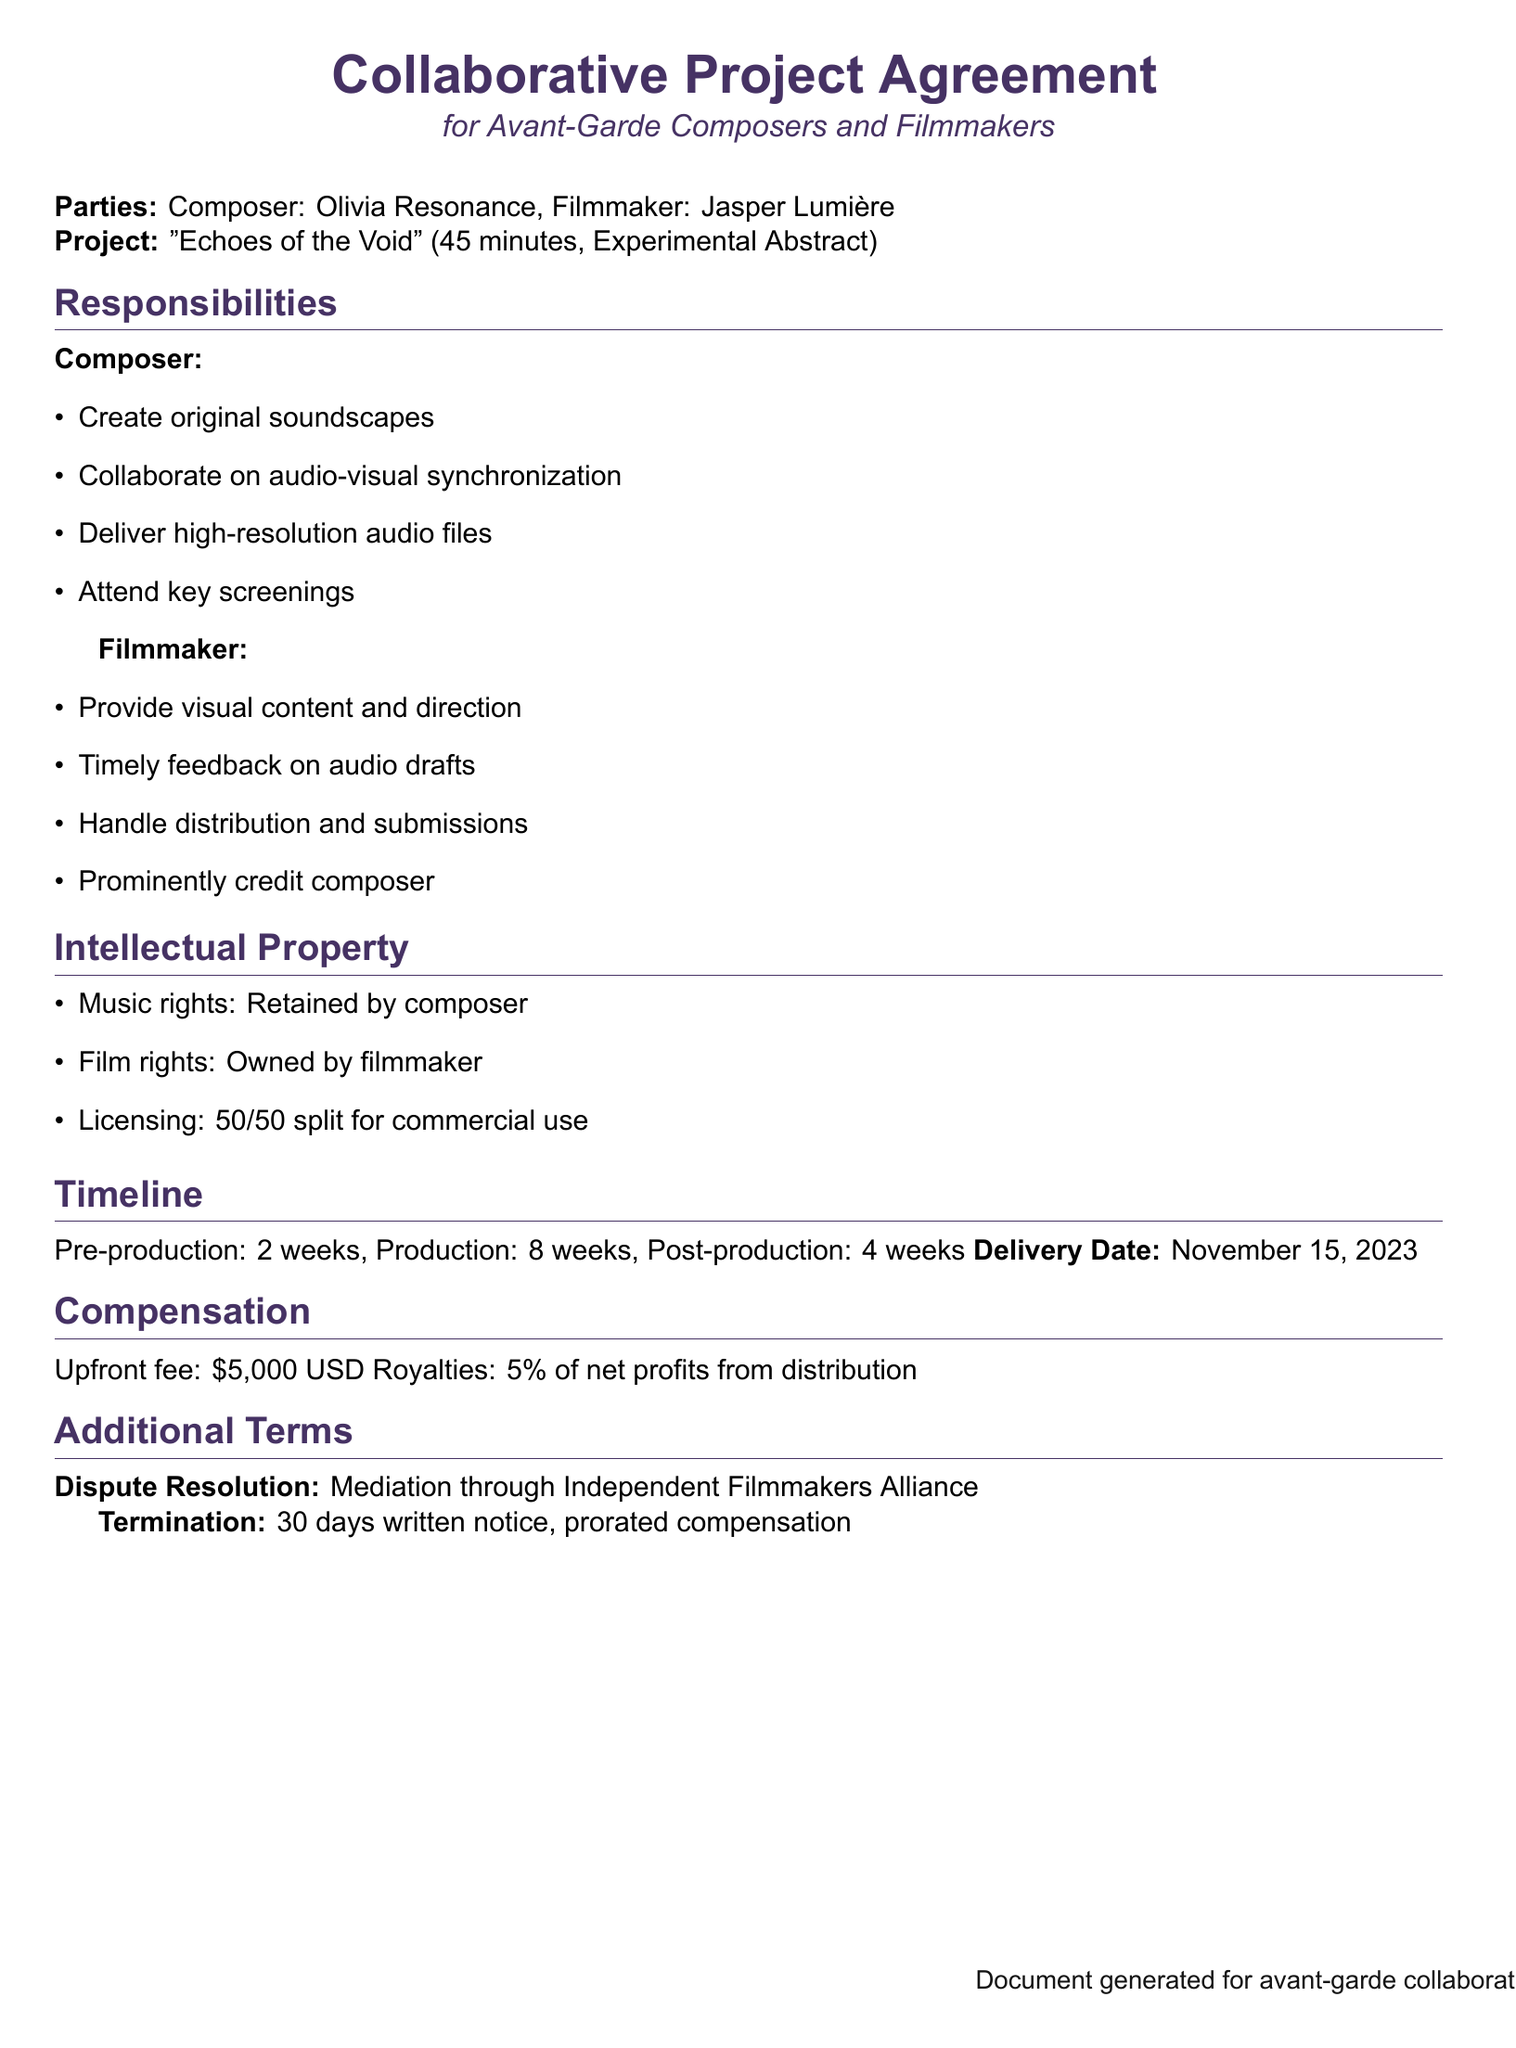What is the name of the composer? The document states that the composer is Olivia Resonance.
Answer: Olivia Resonance What is the name of the filmmaker? The document identifies the filmmaker as Jasper Lumière.
Answer: Jasper Lumière What is the project title? The collaborative project is titled "Echoes of the Void."
Answer: Echoes of the Void What is the delivery date? The document specifies the delivery date as November 15, 2023.
Answer: November 15, 2023 What is the upfront fee for the composer? The document highlights that the upfront fee is \$5,000 USD.
Answer: \$5,000 USD What is the percentage of royalties for the composer? The document states that the composer will receive 5% of net profits.
Answer: 5% What is the timeline for post-production? The document lists 4 weeks for the post-production phase.
Answer: 4 weeks What is the dispute resolution method mentioned? The document specifies mediation through the Independent Filmmakers Alliance.
Answer: Independent Filmmakers Alliance How many weeks are allocated for production? The document indicates that there are 8 weeks allocated for production.
Answer: 8 weeks 